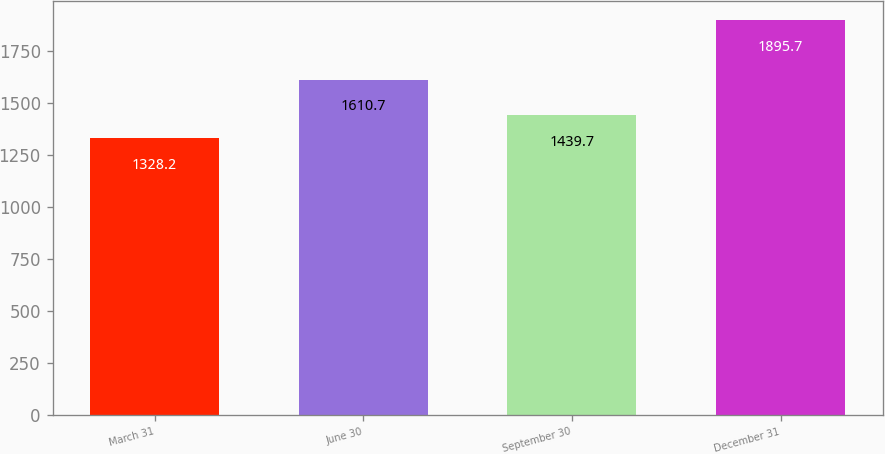Convert chart. <chart><loc_0><loc_0><loc_500><loc_500><bar_chart><fcel>March 31<fcel>June 30<fcel>September 30<fcel>December 31<nl><fcel>1328.2<fcel>1610.7<fcel>1439.7<fcel>1895.7<nl></chart> 